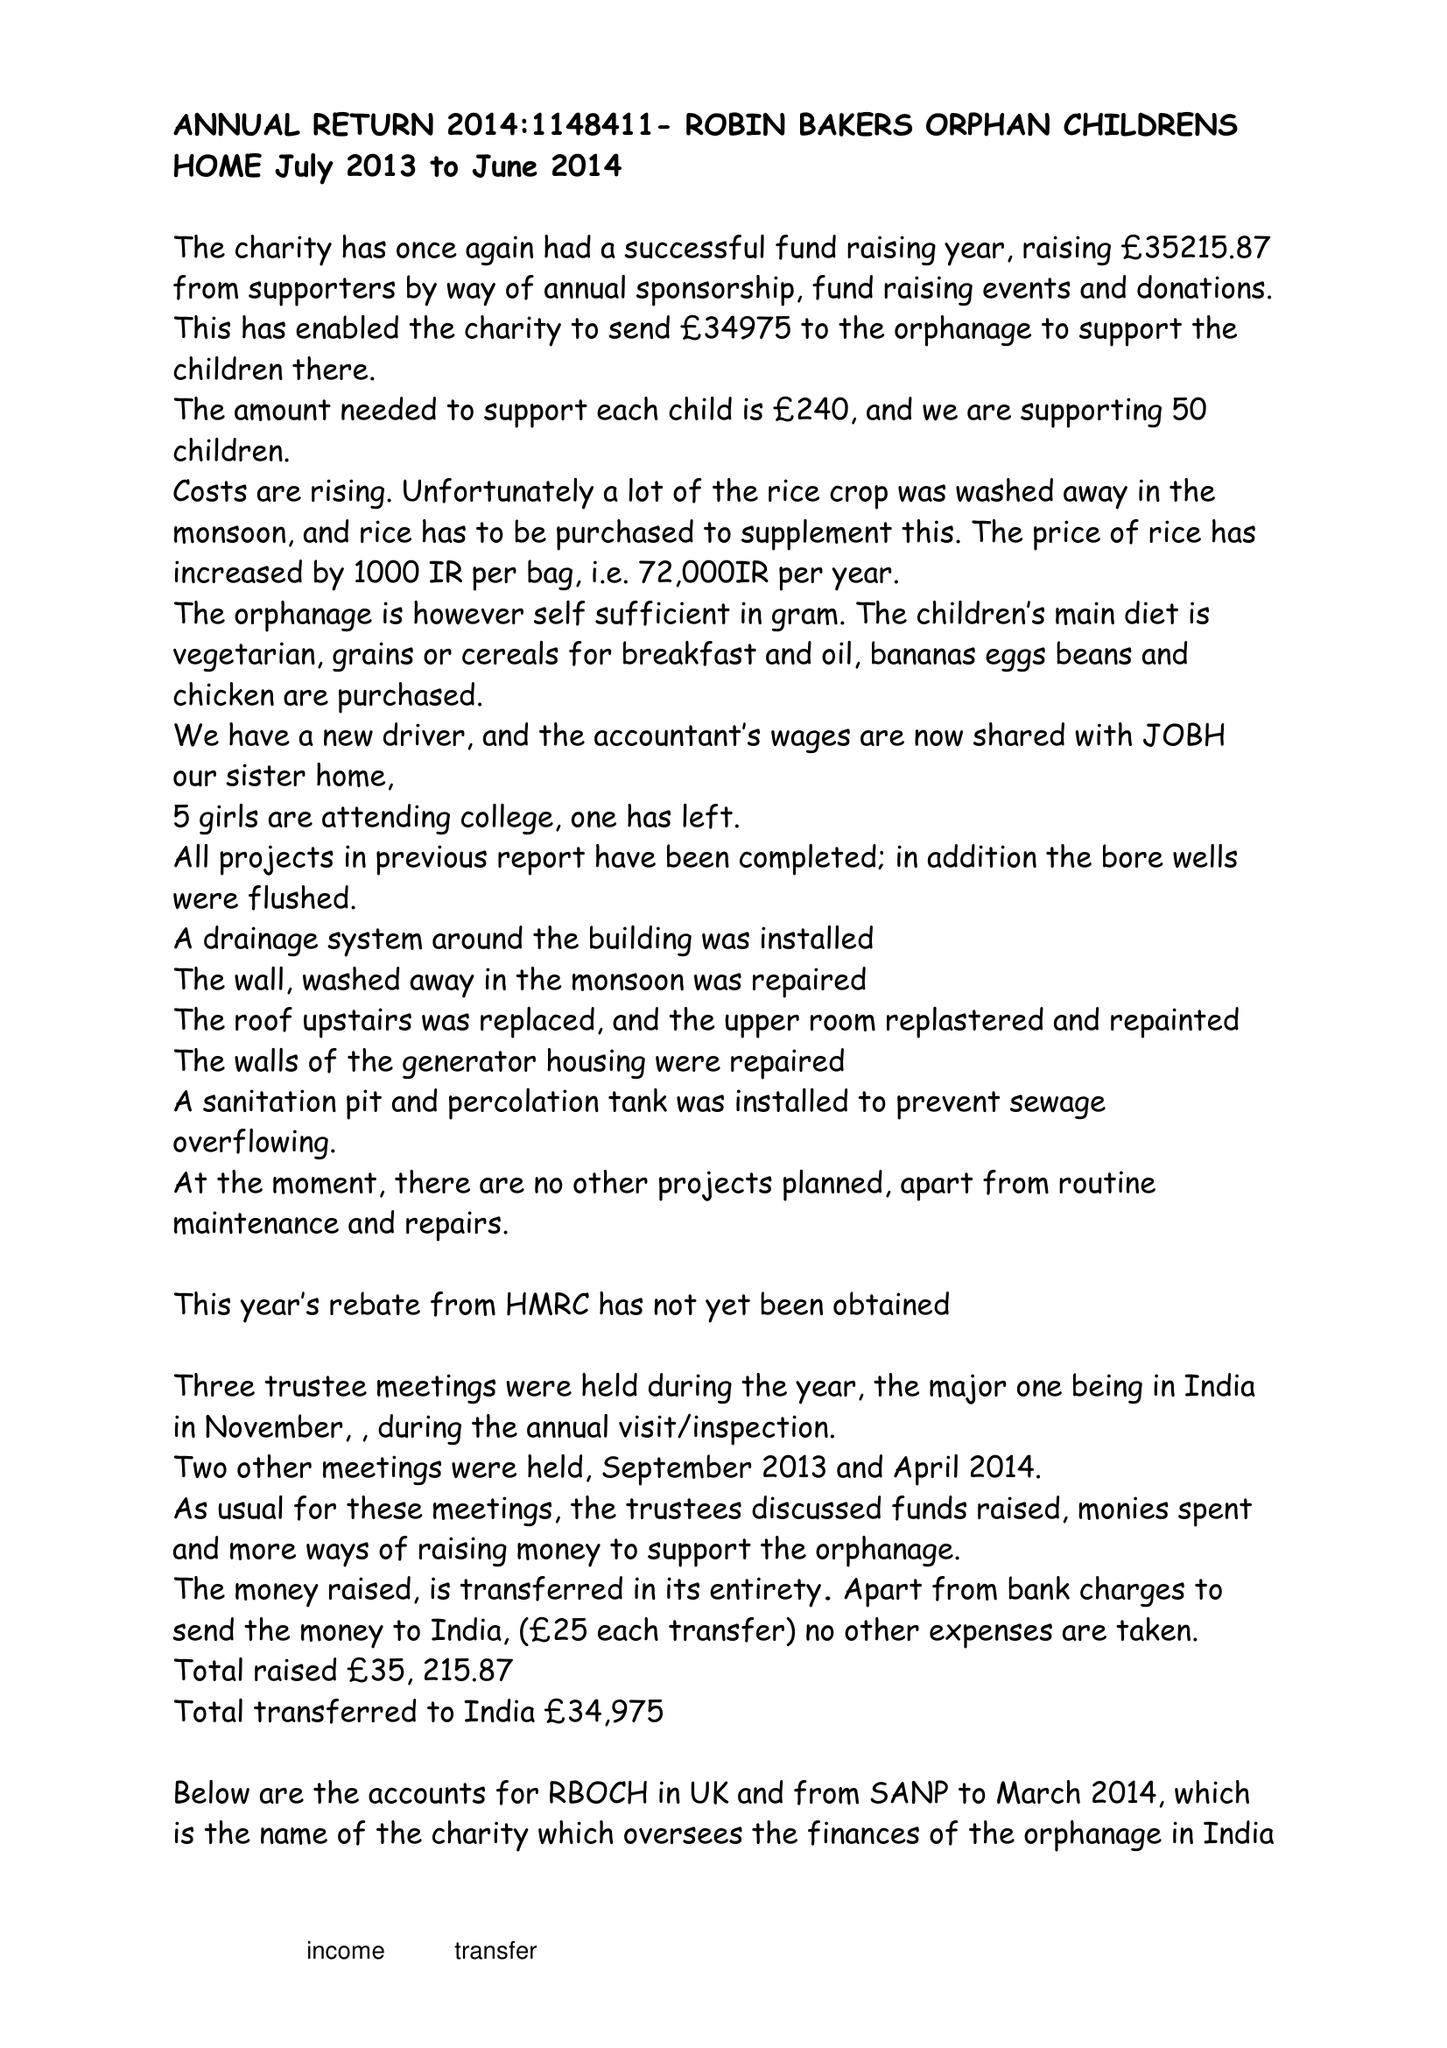What is the value for the charity_number?
Answer the question using a single word or phrase. 1148411 